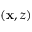<formula> <loc_0><loc_0><loc_500><loc_500>( x , z )</formula> 